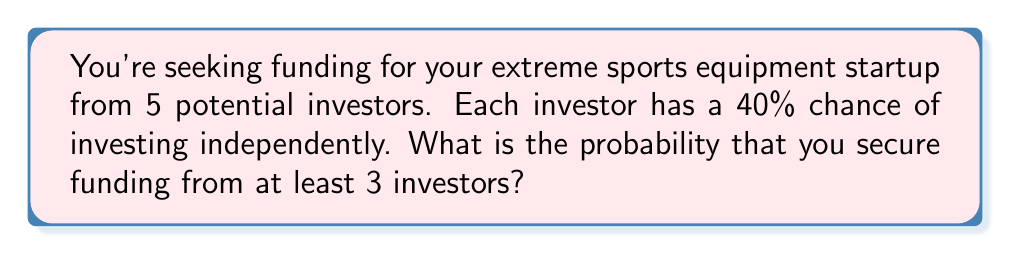Show me your answer to this math problem. Let's approach this step-by-step using the binomial probability distribution:

1) We have $n = 5$ trials (investors), each with probability of success $p = 0.4$.

2) We want the probability of at least 3 successes, which means we need to calculate $P(X \geq 3)$, where $X$ is the number of investors who fund the project.

3) This is equivalent to $1 - P(X < 3)$ or $1 - [P(X = 0) + P(X = 1) + P(X = 2)]$

4) The binomial probability formula is:

   $P(X = k) = \binom{n}{k} p^k (1-p)^{n-k}$

5) Let's calculate each probability:

   $P(X = 0) = \binom{5}{0} (0.4)^0 (0.6)^5 = 1 \cdot 1 \cdot 0.07776 = 0.07776$
   
   $P(X = 1) = \binom{5}{1} (0.4)^1 (0.6)^4 = 5 \cdot 0.4 \cdot 0.1296 = 0.2592$
   
   $P(X = 2) = \binom{5}{2} (0.4)^2 (0.6)^3 = 10 \cdot 0.16 \cdot 0.216 = 0.3456$

6) Sum these probabilities:

   $P(X < 3) = 0.07776 + 0.2592 + 0.3456 = 0.68256$

7) Therefore, the probability of at least 3 investors funding is:

   $P(X \geq 3) = 1 - P(X < 3) = 1 - 0.68256 = 0.31744$
Answer: 0.31744 